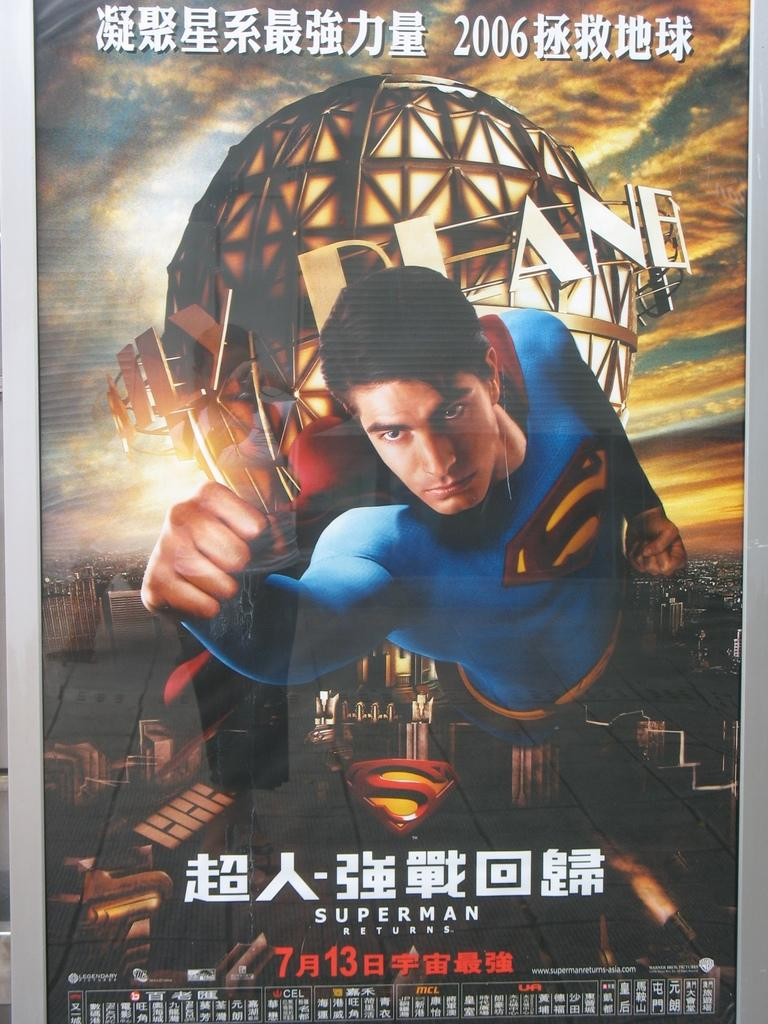<image>
Write a terse but informative summary of the picture. A superman poster with asian text written on it. 